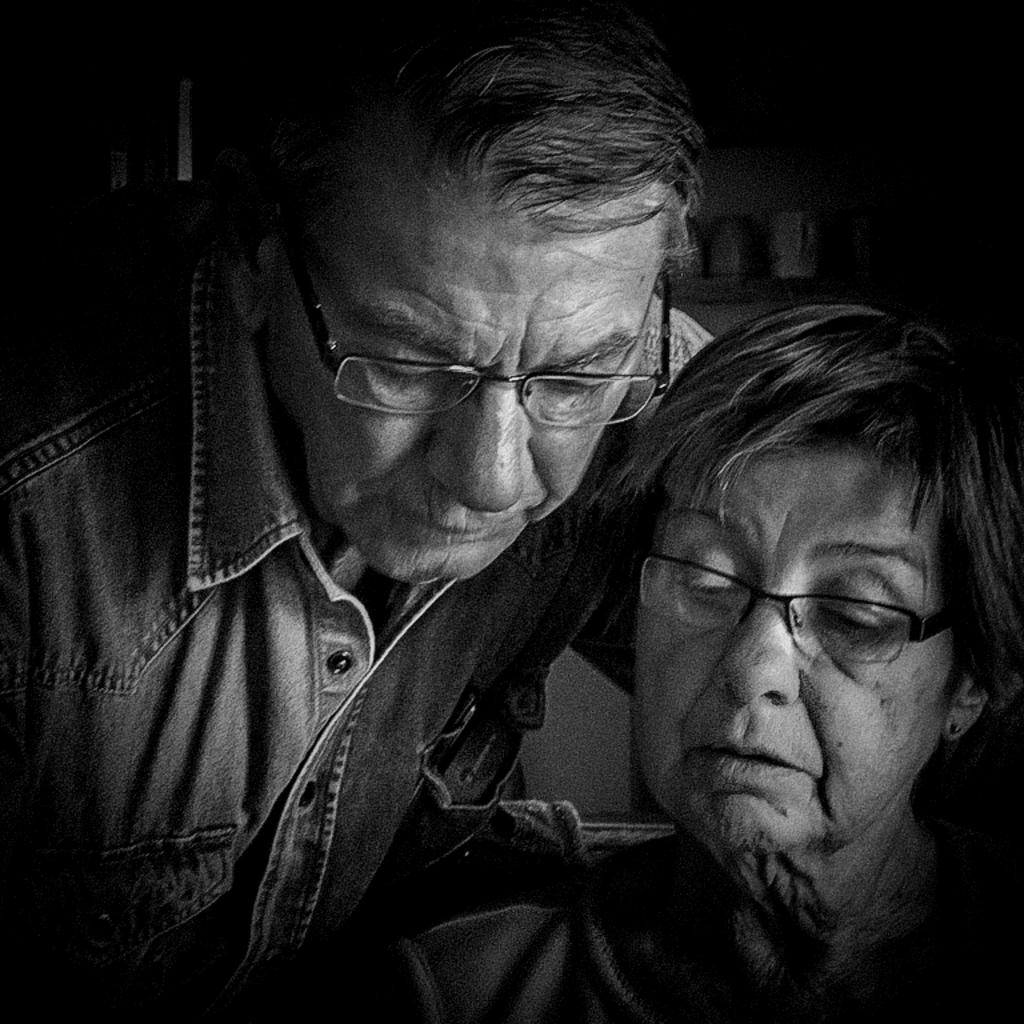What is the lady doing in the image? The lady is sitting on a chair in the image. Who is present behind the lady? There is a man standing behind the lady in the image. What can be seen on the shelf in the background? There is a shelf with cups in the background of the image. What is the cause of death for the lady in the image? There is no indication of death in the image; the lady is sitting on a chair. What is the man's interest in the lady in the image? The image does not provide information about the man's interest in the lady, as it only shows their positions and actions. 